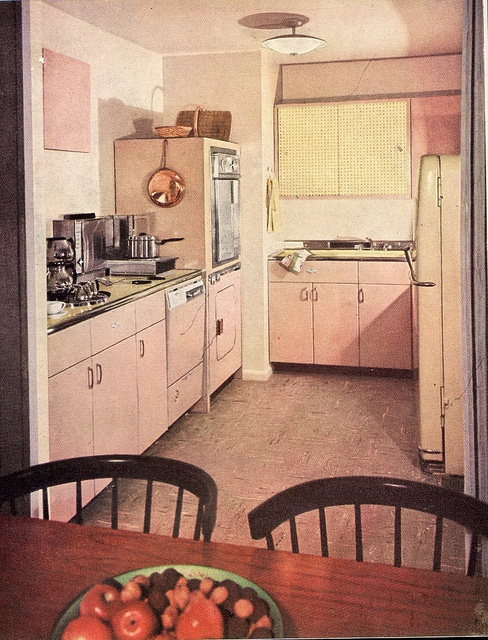Describe the objects in this image and their specific colors. I can see dining table in darkgray, maroon, and brown tones, chair in darkgray, black, brown, maroon, and salmon tones, refrigerator in darkgray and tan tones, chair in darkgray, black, salmon, and gray tones, and oven in darkgray, tan, and lightgray tones in this image. 